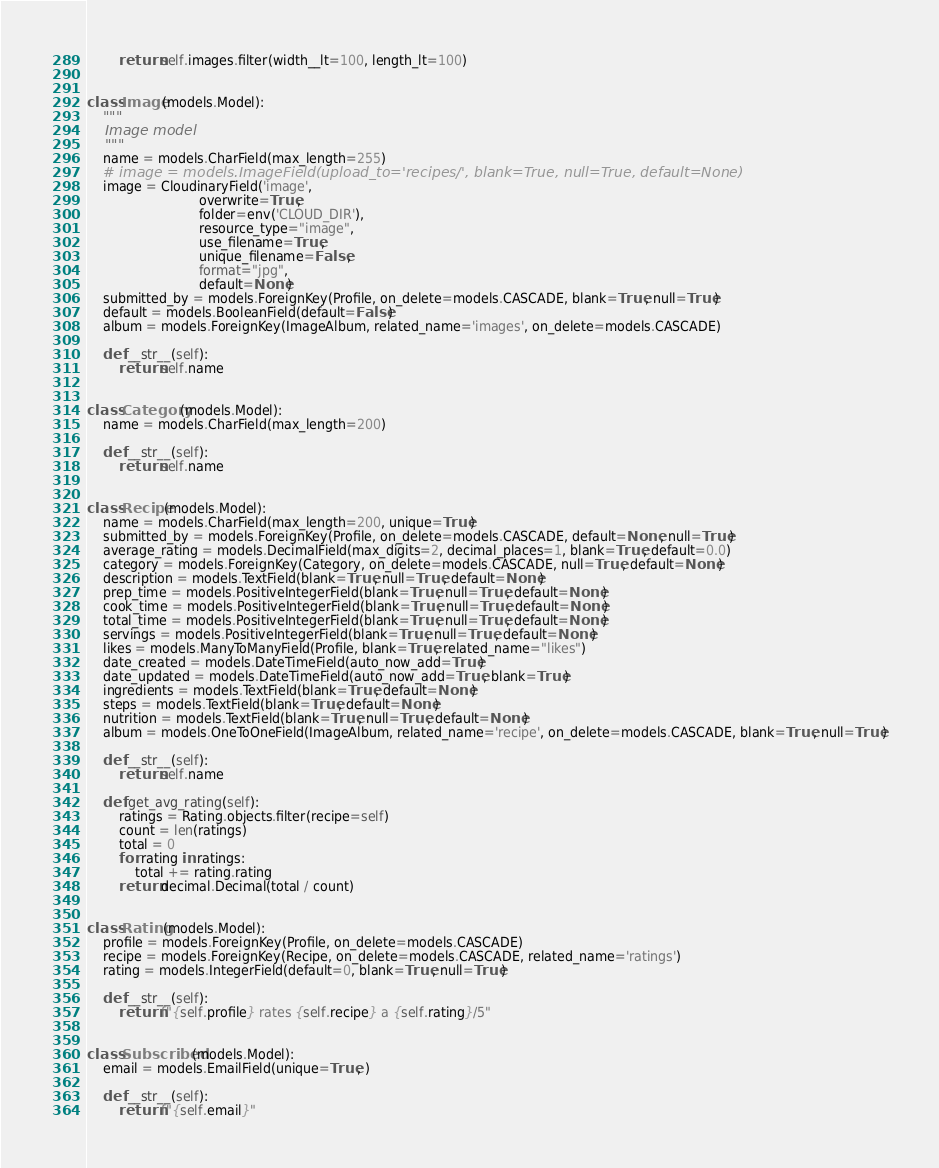<code> <loc_0><loc_0><loc_500><loc_500><_Python_>        return self.images.filter(width__lt=100, length_lt=100)


class Image(models.Model):
    """
    Image model
    """
    name = models.CharField(max_length=255)
    # image = models.ImageField(upload_to='recipes/', blank=True, null=True, default=None)
    image = CloudinaryField('image',
                            overwrite=True,
                            folder=env('CLOUD_DIR'),
                            resource_type="image",
                            use_filename=True,
                            unique_filename=False,
                            format="jpg",
                            default=None)
    submitted_by = models.ForeignKey(Profile, on_delete=models.CASCADE, blank=True, null=True)
    default = models.BooleanField(default=False)
    album = models.ForeignKey(ImageAlbum, related_name='images', on_delete=models.CASCADE)

    def __str__(self):
        return self.name


class Category(models.Model):
    name = models.CharField(max_length=200)

    def __str__(self):
        return self.name


class Recipe(models.Model):
    name = models.CharField(max_length=200, unique=True)
    submitted_by = models.ForeignKey(Profile, on_delete=models.CASCADE, default=None, null=True)
    average_rating = models.DecimalField(max_digits=2, decimal_places=1, blank=True, default=0.0)
    category = models.ForeignKey(Category, on_delete=models.CASCADE, null=True, default=None)
    description = models.TextField(blank=True, null=True, default=None)
    prep_time = models.PositiveIntegerField(blank=True, null=True, default=None)
    cook_time = models.PositiveIntegerField(blank=True, null=True, default=None)
    total_time = models.PositiveIntegerField(blank=True, null=True, default=None)
    servings = models.PositiveIntegerField(blank=True, null=True, default=None)
    likes = models.ManyToManyField(Profile, blank=True, related_name="likes")
    date_created = models.DateTimeField(auto_now_add=True)
    date_updated = models.DateTimeField(auto_now_add=True, blank=True)
    ingredients = models.TextField(blank=True, default=None)
    steps = models.TextField(blank=True, default=None)
    nutrition = models.TextField(blank=True, null=True, default=None)
    album = models.OneToOneField(ImageAlbum, related_name='recipe', on_delete=models.CASCADE, blank=True, null=True)

    def __str__(self):
        return self.name

    def get_avg_rating(self):
        ratings = Rating.objects.filter(recipe=self)
        count = len(ratings)
        total = 0
        for rating in ratings:
            total += rating.rating
        return decimal.Decimal(total / count)


class Rating(models.Model):
    profile = models.ForeignKey(Profile, on_delete=models.CASCADE)
    recipe = models.ForeignKey(Recipe, on_delete=models.CASCADE, related_name='ratings')
    rating = models.IntegerField(default=0, blank=True, null=True)

    def __str__(self):
        return f"{self.profile} rates {self.recipe} a {self.rating}/5"


class Subscribed(models.Model):
    email = models.EmailField(unique=True, )

    def __str__(self):
        return f"{self.email}"
</code> 